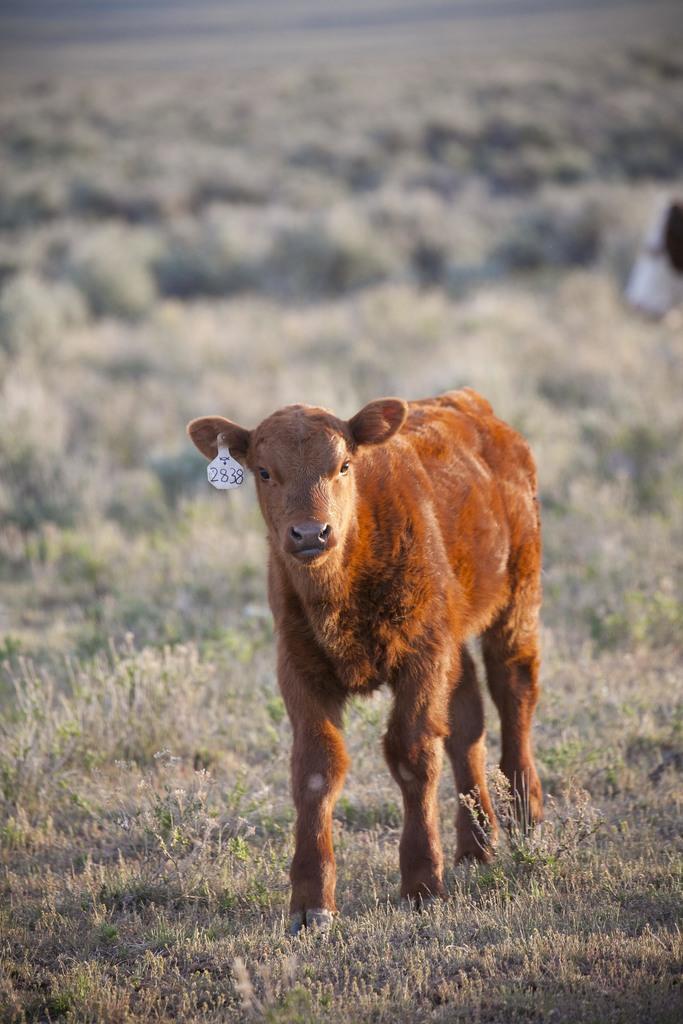Can you describe this image briefly? In this image, there is an animal on blur background. 